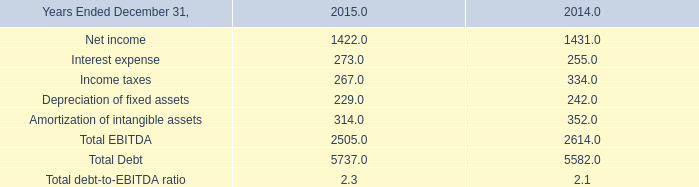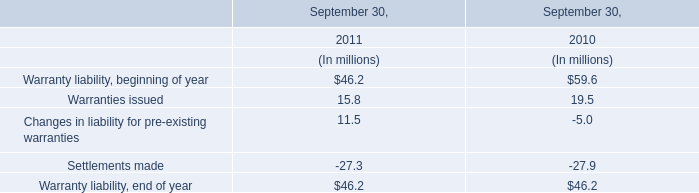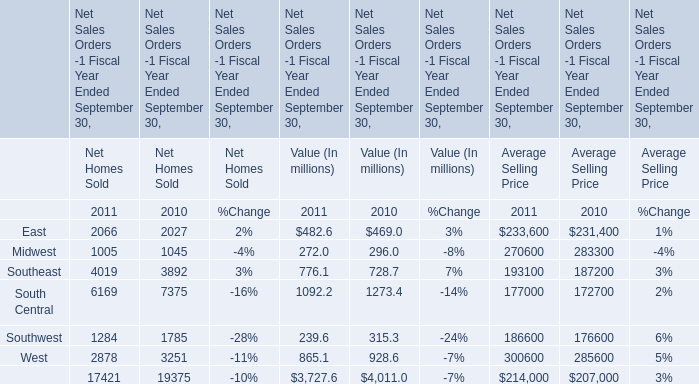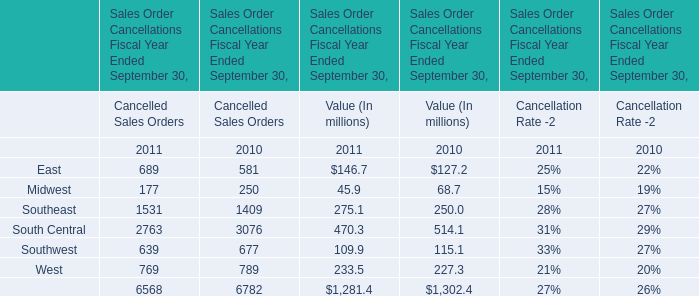What will East for Value (In millions) be like in 2012 if it develops with the same increasing rate as current? (in millions) 
Computations: ((1 + ((482.6 - 469) / 469)) * 482.6)
Answer: 496.59437. 